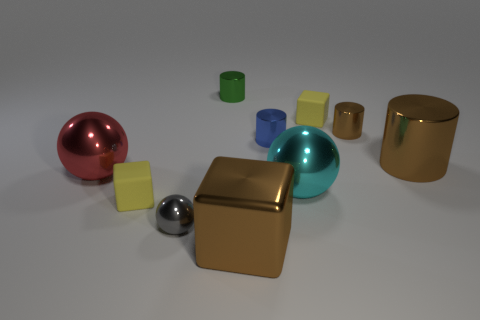Subtract all yellow blocks. How many were subtracted if there are1yellow blocks left? 1 Subtract all large brown metallic cubes. How many cubes are left? 2 Subtract all cyan spheres. How many spheres are left? 2 Subtract all cubes. How many objects are left? 7 Subtract all gray cylinders. How many brown blocks are left? 1 Add 6 big cyan spheres. How many big cyan spheres exist? 7 Subtract 0 purple balls. How many objects are left? 10 Subtract all purple cubes. Subtract all green cylinders. How many cubes are left? 3 Subtract all tiny gray balls. Subtract all tiny rubber things. How many objects are left? 7 Add 1 gray things. How many gray things are left? 2 